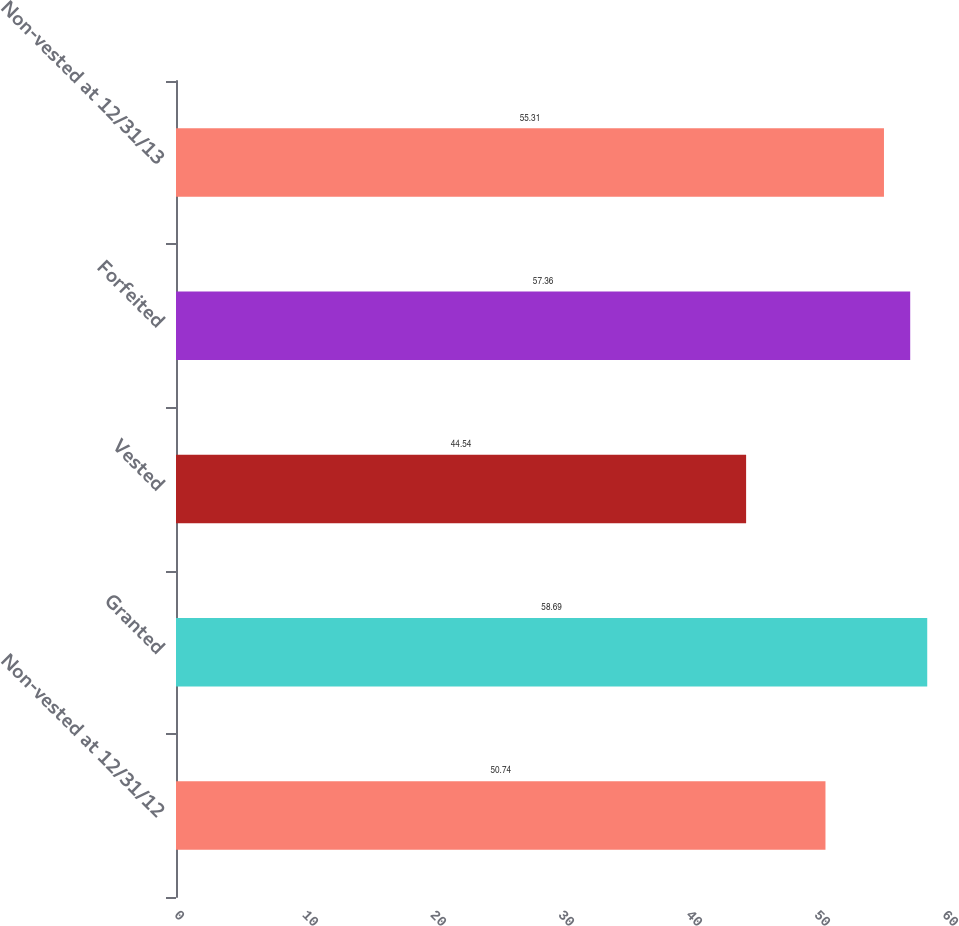Convert chart to OTSL. <chart><loc_0><loc_0><loc_500><loc_500><bar_chart><fcel>Non-vested at 12/31/12<fcel>Granted<fcel>Vested<fcel>Forfeited<fcel>Non-vested at 12/31/13<nl><fcel>50.74<fcel>58.69<fcel>44.54<fcel>57.36<fcel>55.31<nl></chart> 